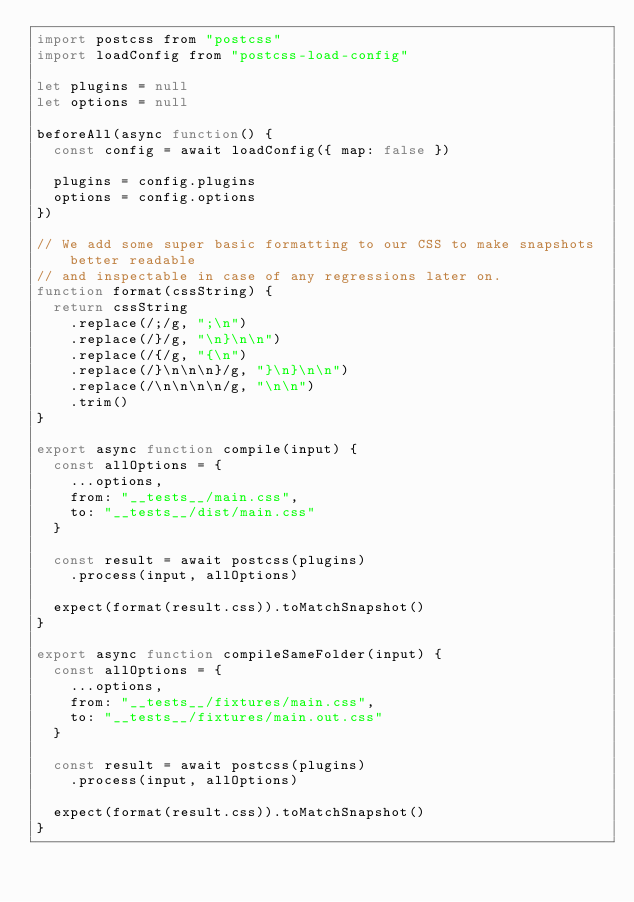Convert code to text. <code><loc_0><loc_0><loc_500><loc_500><_JavaScript_>import postcss from "postcss"
import loadConfig from "postcss-load-config"

let plugins = null
let options = null

beforeAll(async function() {
  const config = await loadConfig({ map: false })

  plugins = config.plugins
  options = config.options
})

// We add some super basic formatting to our CSS to make snapshots better readable
// and inspectable in case of any regressions later on.
function format(cssString) {
  return cssString
    .replace(/;/g, ";\n")
    .replace(/}/g, "\n}\n\n")
    .replace(/{/g, "{\n")
    .replace(/}\n\n\n}/g, "}\n}\n\n")
    .replace(/\n\n\n\n/g, "\n\n")
    .trim()
}

export async function compile(input) {
  const allOptions = {
    ...options,
    from: "__tests__/main.css",
    to: "__tests__/dist/main.css"
  }

  const result = await postcss(plugins)
    .process(input, allOptions)

  expect(format(result.css)).toMatchSnapshot()
}

export async function compileSameFolder(input) {
  const allOptions = {
    ...options,
    from: "__tests__/fixtures/main.css",
    to: "__tests__/fixtures/main.out.css"
  }

  const result = await postcss(plugins)
    .process(input, allOptions)

  expect(format(result.css)).toMatchSnapshot()
}
</code> 